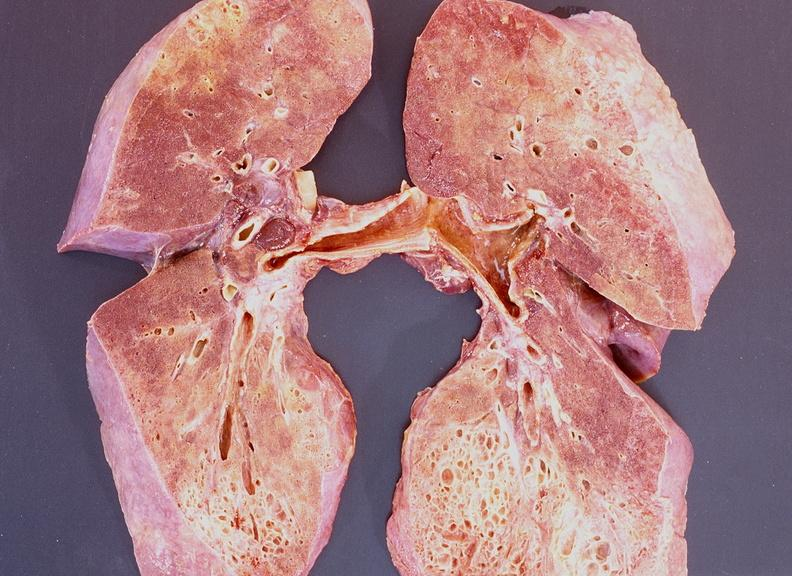s respiratory present?
Answer the question using a single word or phrase. Yes 